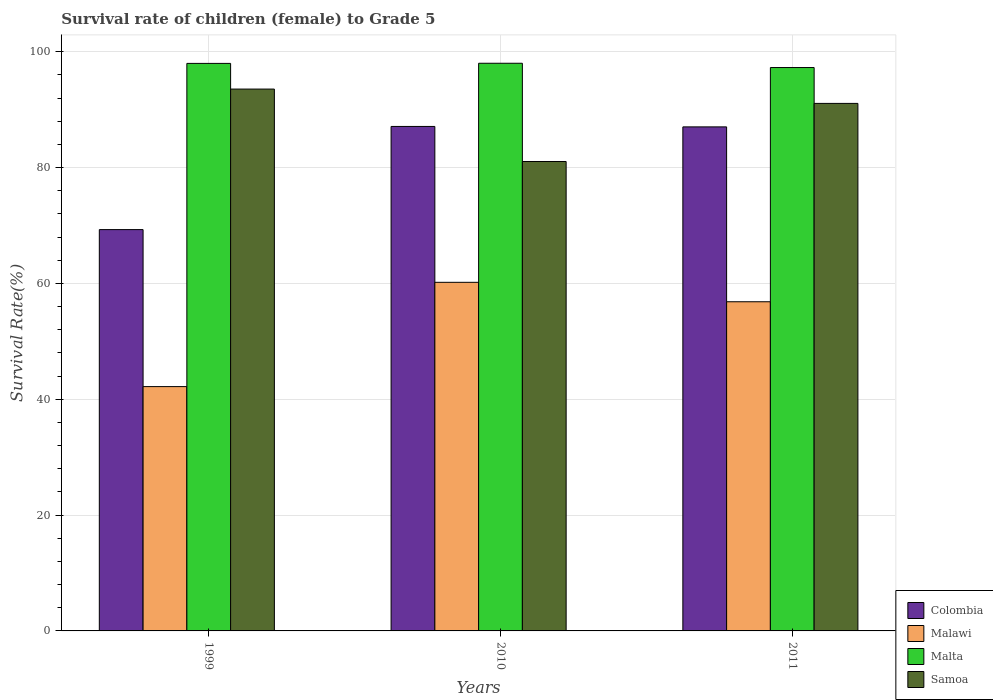How many different coloured bars are there?
Give a very brief answer. 4. How many groups of bars are there?
Keep it short and to the point. 3. Are the number of bars on each tick of the X-axis equal?
Your answer should be very brief. Yes. How many bars are there on the 3rd tick from the left?
Your response must be concise. 4. What is the label of the 1st group of bars from the left?
Provide a succinct answer. 1999. What is the survival rate of female children to grade 5 in Samoa in 2010?
Offer a very short reply. 81.06. Across all years, what is the maximum survival rate of female children to grade 5 in Samoa?
Provide a succinct answer. 93.57. Across all years, what is the minimum survival rate of female children to grade 5 in Samoa?
Offer a terse response. 81.06. In which year was the survival rate of female children to grade 5 in Malta maximum?
Provide a short and direct response. 2010. What is the total survival rate of female children to grade 5 in Malawi in the graph?
Ensure brevity in your answer.  159.23. What is the difference between the survival rate of female children to grade 5 in Malawi in 1999 and that in 2010?
Give a very brief answer. -18.01. What is the difference between the survival rate of female children to grade 5 in Malta in 2010 and the survival rate of female children to grade 5 in Malawi in 1999?
Provide a succinct answer. 55.84. What is the average survival rate of female children to grade 5 in Colombia per year?
Your answer should be very brief. 81.15. In the year 2011, what is the difference between the survival rate of female children to grade 5 in Samoa and survival rate of female children to grade 5 in Malta?
Make the answer very short. -6.19. In how many years, is the survival rate of female children to grade 5 in Malawi greater than 48 %?
Give a very brief answer. 2. What is the ratio of the survival rate of female children to grade 5 in Colombia in 1999 to that in 2011?
Your answer should be compact. 0.8. Is the survival rate of female children to grade 5 in Malta in 2010 less than that in 2011?
Ensure brevity in your answer.  No. Is the difference between the survival rate of female children to grade 5 in Samoa in 1999 and 2010 greater than the difference between the survival rate of female children to grade 5 in Malta in 1999 and 2010?
Your answer should be very brief. Yes. What is the difference between the highest and the second highest survival rate of female children to grade 5 in Samoa?
Your answer should be compact. 2.47. What is the difference between the highest and the lowest survival rate of female children to grade 5 in Colombia?
Give a very brief answer. 17.81. Is the sum of the survival rate of female children to grade 5 in Colombia in 1999 and 2011 greater than the maximum survival rate of female children to grade 5 in Malta across all years?
Ensure brevity in your answer.  Yes. What does the 2nd bar from the left in 2010 represents?
Offer a terse response. Malawi. What does the 3rd bar from the right in 2011 represents?
Give a very brief answer. Malawi. How many bars are there?
Keep it short and to the point. 12. Are all the bars in the graph horizontal?
Your response must be concise. No. What is the difference between two consecutive major ticks on the Y-axis?
Give a very brief answer. 20. Does the graph contain any zero values?
Make the answer very short. No. Where does the legend appear in the graph?
Your answer should be very brief. Bottom right. How are the legend labels stacked?
Offer a very short reply. Vertical. What is the title of the graph?
Your answer should be compact. Survival rate of children (female) to Grade 5. What is the label or title of the Y-axis?
Ensure brevity in your answer.  Survival Rate(%). What is the Survival Rate(%) in Colombia in 1999?
Your answer should be compact. 69.3. What is the Survival Rate(%) in Malawi in 1999?
Make the answer very short. 42.19. What is the Survival Rate(%) of Malta in 1999?
Your answer should be very brief. 98. What is the Survival Rate(%) of Samoa in 1999?
Your answer should be very brief. 93.57. What is the Survival Rate(%) in Colombia in 2010?
Provide a short and direct response. 87.11. What is the Survival Rate(%) of Malawi in 2010?
Your response must be concise. 60.2. What is the Survival Rate(%) in Malta in 2010?
Your answer should be very brief. 98.03. What is the Survival Rate(%) in Samoa in 2010?
Provide a short and direct response. 81.06. What is the Survival Rate(%) in Colombia in 2011?
Offer a very short reply. 87.04. What is the Survival Rate(%) of Malawi in 2011?
Make the answer very short. 56.84. What is the Survival Rate(%) of Malta in 2011?
Keep it short and to the point. 97.29. What is the Survival Rate(%) in Samoa in 2011?
Ensure brevity in your answer.  91.09. Across all years, what is the maximum Survival Rate(%) of Colombia?
Keep it short and to the point. 87.11. Across all years, what is the maximum Survival Rate(%) in Malawi?
Provide a short and direct response. 60.2. Across all years, what is the maximum Survival Rate(%) of Malta?
Provide a short and direct response. 98.03. Across all years, what is the maximum Survival Rate(%) of Samoa?
Keep it short and to the point. 93.57. Across all years, what is the minimum Survival Rate(%) of Colombia?
Provide a succinct answer. 69.3. Across all years, what is the minimum Survival Rate(%) in Malawi?
Ensure brevity in your answer.  42.19. Across all years, what is the minimum Survival Rate(%) of Malta?
Provide a short and direct response. 97.29. Across all years, what is the minimum Survival Rate(%) of Samoa?
Keep it short and to the point. 81.06. What is the total Survival Rate(%) of Colombia in the graph?
Ensure brevity in your answer.  243.45. What is the total Survival Rate(%) in Malawi in the graph?
Give a very brief answer. 159.23. What is the total Survival Rate(%) of Malta in the graph?
Ensure brevity in your answer.  293.31. What is the total Survival Rate(%) in Samoa in the graph?
Your response must be concise. 265.72. What is the difference between the Survival Rate(%) of Colombia in 1999 and that in 2010?
Offer a very short reply. -17.81. What is the difference between the Survival Rate(%) of Malawi in 1999 and that in 2010?
Provide a succinct answer. -18.01. What is the difference between the Survival Rate(%) of Malta in 1999 and that in 2010?
Keep it short and to the point. -0.02. What is the difference between the Survival Rate(%) in Samoa in 1999 and that in 2010?
Your response must be concise. 12.51. What is the difference between the Survival Rate(%) of Colombia in 1999 and that in 2011?
Offer a very short reply. -17.74. What is the difference between the Survival Rate(%) in Malawi in 1999 and that in 2011?
Offer a terse response. -14.65. What is the difference between the Survival Rate(%) of Samoa in 1999 and that in 2011?
Your answer should be compact. 2.47. What is the difference between the Survival Rate(%) in Colombia in 2010 and that in 2011?
Offer a very short reply. 0.07. What is the difference between the Survival Rate(%) in Malawi in 2010 and that in 2011?
Give a very brief answer. 3.36. What is the difference between the Survival Rate(%) of Malta in 2010 and that in 2011?
Offer a very short reply. 0.74. What is the difference between the Survival Rate(%) of Samoa in 2010 and that in 2011?
Give a very brief answer. -10.03. What is the difference between the Survival Rate(%) in Colombia in 1999 and the Survival Rate(%) in Malawi in 2010?
Offer a terse response. 9.1. What is the difference between the Survival Rate(%) of Colombia in 1999 and the Survival Rate(%) of Malta in 2010?
Your response must be concise. -28.72. What is the difference between the Survival Rate(%) in Colombia in 1999 and the Survival Rate(%) in Samoa in 2010?
Provide a short and direct response. -11.76. What is the difference between the Survival Rate(%) in Malawi in 1999 and the Survival Rate(%) in Malta in 2010?
Keep it short and to the point. -55.84. What is the difference between the Survival Rate(%) in Malawi in 1999 and the Survival Rate(%) in Samoa in 2010?
Make the answer very short. -38.87. What is the difference between the Survival Rate(%) of Malta in 1999 and the Survival Rate(%) of Samoa in 2010?
Your response must be concise. 16.94. What is the difference between the Survival Rate(%) in Colombia in 1999 and the Survival Rate(%) in Malawi in 2011?
Your answer should be very brief. 12.46. What is the difference between the Survival Rate(%) in Colombia in 1999 and the Survival Rate(%) in Malta in 2011?
Your response must be concise. -27.98. What is the difference between the Survival Rate(%) of Colombia in 1999 and the Survival Rate(%) of Samoa in 2011?
Give a very brief answer. -21.79. What is the difference between the Survival Rate(%) in Malawi in 1999 and the Survival Rate(%) in Malta in 2011?
Your answer should be very brief. -55.1. What is the difference between the Survival Rate(%) in Malawi in 1999 and the Survival Rate(%) in Samoa in 2011?
Provide a succinct answer. -48.9. What is the difference between the Survival Rate(%) of Malta in 1999 and the Survival Rate(%) of Samoa in 2011?
Give a very brief answer. 6.91. What is the difference between the Survival Rate(%) of Colombia in 2010 and the Survival Rate(%) of Malawi in 2011?
Your answer should be very brief. 30.27. What is the difference between the Survival Rate(%) of Colombia in 2010 and the Survival Rate(%) of Malta in 2011?
Make the answer very short. -10.17. What is the difference between the Survival Rate(%) in Colombia in 2010 and the Survival Rate(%) in Samoa in 2011?
Your response must be concise. -3.98. What is the difference between the Survival Rate(%) in Malawi in 2010 and the Survival Rate(%) in Malta in 2011?
Keep it short and to the point. -37.09. What is the difference between the Survival Rate(%) in Malawi in 2010 and the Survival Rate(%) in Samoa in 2011?
Your answer should be compact. -30.9. What is the difference between the Survival Rate(%) of Malta in 2010 and the Survival Rate(%) of Samoa in 2011?
Your answer should be compact. 6.93. What is the average Survival Rate(%) of Colombia per year?
Your answer should be compact. 81.15. What is the average Survival Rate(%) in Malawi per year?
Offer a terse response. 53.08. What is the average Survival Rate(%) in Malta per year?
Provide a short and direct response. 97.77. What is the average Survival Rate(%) in Samoa per year?
Give a very brief answer. 88.57. In the year 1999, what is the difference between the Survival Rate(%) in Colombia and Survival Rate(%) in Malawi?
Offer a very short reply. 27.11. In the year 1999, what is the difference between the Survival Rate(%) of Colombia and Survival Rate(%) of Malta?
Your response must be concise. -28.7. In the year 1999, what is the difference between the Survival Rate(%) in Colombia and Survival Rate(%) in Samoa?
Offer a terse response. -24.27. In the year 1999, what is the difference between the Survival Rate(%) of Malawi and Survival Rate(%) of Malta?
Provide a succinct answer. -55.81. In the year 1999, what is the difference between the Survival Rate(%) in Malawi and Survival Rate(%) in Samoa?
Offer a very short reply. -51.38. In the year 1999, what is the difference between the Survival Rate(%) in Malta and Survival Rate(%) in Samoa?
Keep it short and to the point. 4.43. In the year 2010, what is the difference between the Survival Rate(%) of Colombia and Survival Rate(%) of Malawi?
Provide a short and direct response. 26.92. In the year 2010, what is the difference between the Survival Rate(%) in Colombia and Survival Rate(%) in Malta?
Provide a short and direct response. -10.91. In the year 2010, what is the difference between the Survival Rate(%) of Colombia and Survival Rate(%) of Samoa?
Your answer should be compact. 6.05. In the year 2010, what is the difference between the Survival Rate(%) of Malawi and Survival Rate(%) of Malta?
Offer a very short reply. -37.83. In the year 2010, what is the difference between the Survival Rate(%) in Malawi and Survival Rate(%) in Samoa?
Provide a short and direct response. -20.86. In the year 2010, what is the difference between the Survival Rate(%) of Malta and Survival Rate(%) of Samoa?
Provide a short and direct response. 16.96. In the year 2011, what is the difference between the Survival Rate(%) in Colombia and Survival Rate(%) in Malawi?
Provide a succinct answer. 30.2. In the year 2011, what is the difference between the Survival Rate(%) in Colombia and Survival Rate(%) in Malta?
Offer a very short reply. -10.25. In the year 2011, what is the difference between the Survival Rate(%) of Colombia and Survival Rate(%) of Samoa?
Ensure brevity in your answer.  -4.06. In the year 2011, what is the difference between the Survival Rate(%) of Malawi and Survival Rate(%) of Malta?
Keep it short and to the point. -40.45. In the year 2011, what is the difference between the Survival Rate(%) in Malawi and Survival Rate(%) in Samoa?
Your answer should be compact. -34.25. In the year 2011, what is the difference between the Survival Rate(%) in Malta and Survival Rate(%) in Samoa?
Your answer should be compact. 6.19. What is the ratio of the Survival Rate(%) of Colombia in 1999 to that in 2010?
Your response must be concise. 0.8. What is the ratio of the Survival Rate(%) in Malawi in 1999 to that in 2010?
Provide a short and direct response. 0.7. What is the ratio of the Survival Rate(%) of Malta in 1999 to that in 2010?
Give a very brief answer. 1. What is the ratio of the Survival Rate(%) in Samoa in 1999 to that in 2010?
Offer a terse response. 1.15. What is the ratio of the Survival Rate(%) of Colombia in 1999 to that in 2011?
Your response must be concise. 0.8. What is the ratio of the Survival Rate(%) of Malawi in 1999 to that in 2011?
Your response must be concise. 0.74. What is the ratio of the Survival Rate(%) in Malta in 1999 to that in 2011?
Your answer should be compact. 1.01. What is the ratio of the Survival Rate(%) in Samoa in 1999 to that in 2011?
Offer a terse response. 1.03. What is the ratio of the Survival Rate(%) in Malawi in 2010 to that in 2011?
Provide a short and direct response. 1.06. What is the ratio of the Survival Rate(%) of Malta in 2010 to that in 2011?
Offer a very short reply. 1.01. What is the ratio of the Survival Rate(%) of Samoa in 2010 to that in 2011?
Your answer should be compact. 0.89. What is the difference between the highest and the second highest Survival Rate(%) in Colombia?
Give a very brief answer. 0.07. What is the difference between the highest and the second highest Survival Rate(%) of Malawi?
Your response must be concise. 3.36. What is the difference between the highest and the second highest Survival Rate(%) in Malta?
Your response must be concise. 0.02. What is the difference between the highest and the second highest Survival Rate(%) in Samoa?
Keep it short and to the point. 2.47. What is the difference between the highest and the lowest Survival Rate(%) in Colombia?
Keep it short and to the point. 17.81. What is the difference between the highest and the lowest Survival Rate(%) of Malawi?
Keep it short and to the point. 18.01. What is the difference between the highest and the lowest Survival Rate(%) of Malta?
Provide a short and direct response. 0.74. What is the difference between the highest and the lowest Survival Rate(%) of Samoa?
Provide a short and direct response. 12.51. 